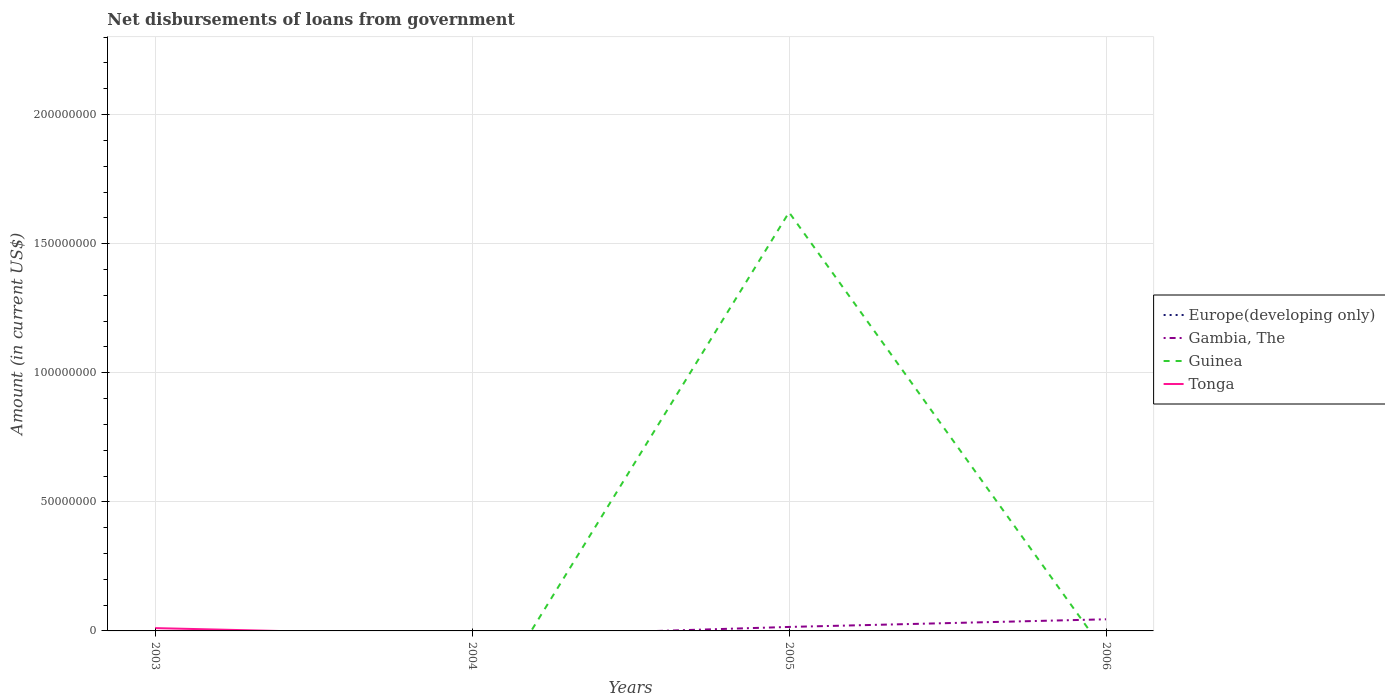How many different coloured lines are there?
Provide a short and direct response. 3. Is the number of lines equal to the number of legend labels?
Offer a very short reply. No. What is the difference between the highest and the second highest amount of loan disbursed from government in Guinea?
Make the answer very short. 1.62e+08. What is the difference between the highest and the lowest amount of loan disbursed from government in Europe(developing only)?
Offer a very short reply. 0. What is the difference between two consecutive major ticks on the Y-axis?
Keep it short and to the point. 5.00e+07. Does the graph contain grids?
Your answer should be compact. Yes. Where does the legend appear in the graph?
Provide a succinct answer. Center right. What is the title of the graph?
Offer a very short reply. Net disbursements of loans from government. What is the label or title of the X-axis?
Your response must be concise. Years. What is the label or title of the Y-axis?
Provide a succinct answer. Amount (in current US$). What is the Amount (in current US$) in Europe(developing only) in 2003?
Offer a terse response. 0. What is the Amount (in current US$) of Guinea in 2003?
Keep it short and to the point. 0. What is the Amount (in current US$) in Tonga in 2003?
Provide a succinct answer. 1.09e+06. What is the Amount (in current US$) in Guinea in 2004?
Provide a short and direct response. 0. What is the Amount (in current US$) of Gambia, The in 2005?
Your response must be concise. 1.54e+06. What is the Amount (in current US$) of Guinea in 2005?
Your answer should be compact. 1.62e+08. What is the Amount (in current US$) in Europe(developing only) in 2006?
Provide a succinct answer. 0. What is the Amount (in current US$) of Gambia, The in 2006?
Offer a very short reply. 4.50e+06. What is the Amount (in current US$) of Tonga in 2006?
Your answer should be compact. 0. Across all years, what is the maximum Amount (in current US$) of Gambia, The?
Provide a short and direct response. 4.50e+06. Across all years, what is the maximum Amount (in current US$) in Guinea?
Make the answer very short. 1.62e+08. Across all years, what is the maximum Amount (in current US$) in Tonga?
Offer a very short reply. 1.09e+06. Across all years, what is the minimum Amount (in current US$) of Gambia, The?
Offer a terse response. 0. Across all years, what is the minimum Amount (in current US$) of Guinea?
Your answer should be compact. 0. What is the total Amount (in current US$) in Europe(developing only) in the graph?
Offer a terse response. 0. What is the total Amount (in current US$) in Gambia, The in the graph?
Make the answer very short. 6.05e+06. What is the total Amount (in current US$) in Guinea in the graph?
Give a very brief answer. 1.62e+08. What is the total Amount (in current US$) in Tonga in the graph?
Offer a very short reply. 1.09e+06. What is the difference between the Amount (in current US$) in Gambia, The in 2005 and that in 2006?
Ensure brevity in your answer.  -2.96e+06. What is the average Amount (in current US$) of Gambia, The per year?
Give a very brief answer. 1.51e+06. What is the average Amount (in current US$) in Guinea per year?
Your response must be concise. 4.05e+07. What is the average Amount (in current US$) of Tonga per year?
Give a very brief answer. 2.72e+05. In the year 2005, what is the difference between the Amount (in current US$) in Gambia, The and Amount (in current US$) in Guinea?
Ensure brevity in your answer.  -1.61e+08. What is the ratio of the Amount (in current US$) in Gambia, The in 2005 to that in 2006?
Ensure brevity in your answer.  0.34. What is the difference between the highest and the lowest Amount (in current US$) in Gambia, The?
Provide a short and direct response. 4.50e+06. What is the difference between the highest and the lowest Amount (in current US$) of Guinea?
Provide a succinct answer. 1.62e+08. What is the difference between the highest and the lowest Amount (in current US$) in Tonga?
Keep it short and to the point. 1.09e+06. 